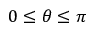<formula> <loc_0><loc_0><loc_500><loc_500>0 \leq \theta \leq \pi</formula> 